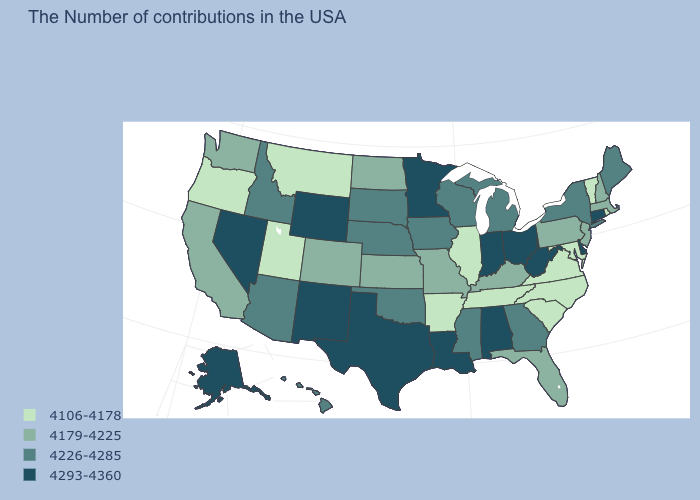What is the value of Maryland?
Concise answer only. 4106-4178. What is the value of Oklahoma?
Write a very short answer. 4226-4285. What is the value of New York?
Write a very short answer. 4226-4285. Among the states that border New York , does Massachusetts have the lowest value?
Quick response, please. No. Does the first symbol in the legend represent the smallest category?
Keep it brief. Yes. Which states hav the highest value in the Northeast?
Answer briefly. Connecticut. What is the highest value in the MidWest ?
Quick response, please. 4293-4360. What is the lowest value in states that border Michigan?
Answer briefly. 4226-4285. Does Texas have a higher value than Idaho?
Be succinct. Yes. What is the value of Arizona?
Short answer required. 4226-4285. Among the states that border New York , which have the highest value?
Be succinct. Connecticut. Does New Hampshire have a higher value than New Jersey?
Concise answer only. No. Does Washington have the highest value in the USA?
Answer briefly. No. Does Alabama have the same value as Maine?
Write a very short answer. No. Among the states that border California , does Oregon have the lowest value?
Write a very short answer. Yes. 